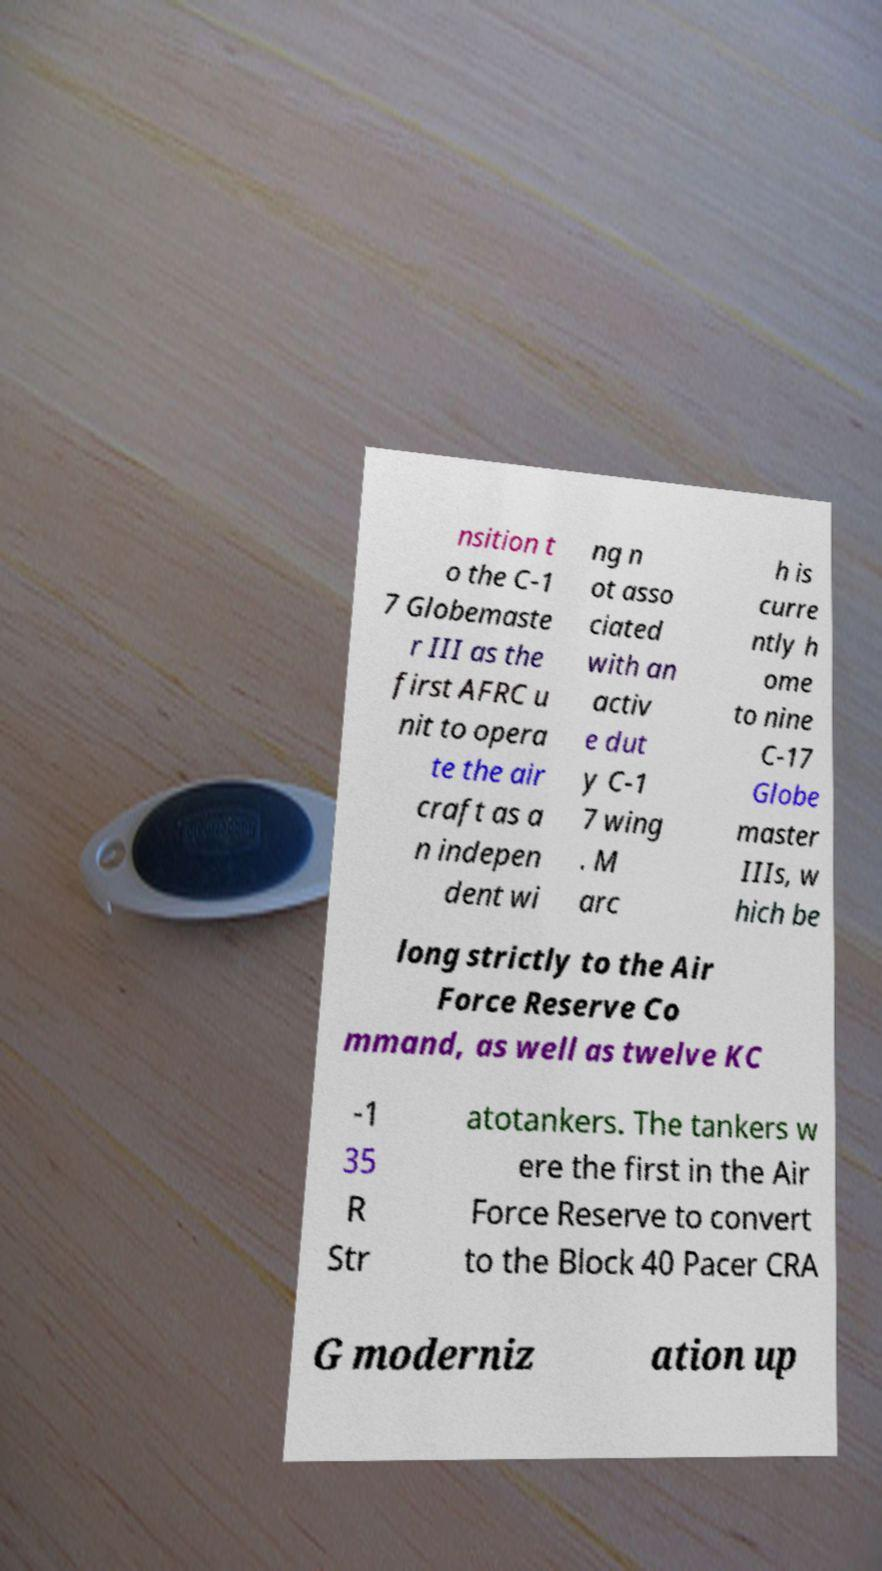Could you extract and type out the text from this image? nsition t o the C-1 7 Globemaste r III as the first AFRC u nit to opera te the air craft as a n indepen dent wi ng n ot asso ciated with an activ e dut y C-1 7 wing . M arc h is curre ntly h ome to nine C-17 Globe master IIIs, w hich be long strictly to the Air Force Reserve Co mmand, as well as twelve KC -1 35 R Str atotankers. The tankers w ere the first in the Air Force Reserve to convert to the Block 40 Pacer CRA G moderniz ation up 